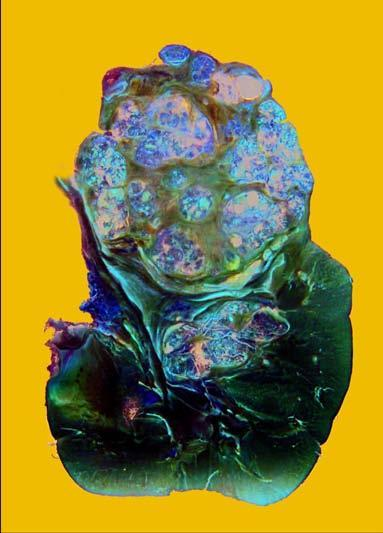does the colour of sectioned surface have reniform contour?
Answer the question using a single word or phrase. No 